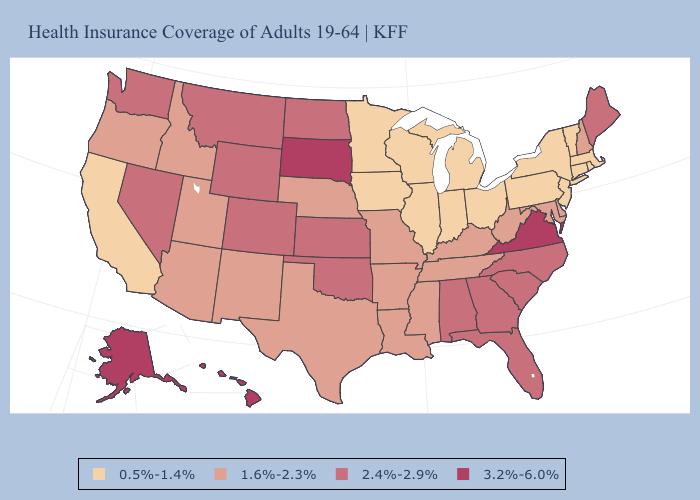Is the legend a continuous bar?
Write a very short answer. No. Name the states that have a value in the range 2.4%-2.9%?
Answer briefly. Alabama, Colorado, Florida, Georgia, Kansas, Maine, Montana, Nevada, North Carolina, North Dakota, Oklahoma, South Carolina, Washington, Wyoming. Name the states that have a value in the range 1.6%-2.3%?
Give a very brief answer. Arizona, Arkansas, Delaware, Idaho, Kentucky, Louisiana, Maryland, Mississippi, Missouri, Nebraska, New Hampshire, New Mexico, Oregon, Tennessee, Texas, Utah, West Virginia. Does Louisiana have a higher value than Hawaii?
Answer briefly. No. Among the states that border Kansas , does Nebraska have the lowest value?
Answer briefly. Yes. What is the value of Virginia?
Give a very brief answer. 3.2%-6.0%. What is the lowest value in states that border Maryland?
Keep it brief. 0.5%-1.4%. Among the states that border Colorado , does Kansas have the lowest value?
Write a very short answer. No. Which states have the highest value in the USA?
Keep it brief. Alaska, Hawaii, South Dakota, Virginia. What is the lowest value in the West?
Be succinct. 0.5%-1.4%. Name the states that have a value in the range 2.4%-2.9%?
Quick response, please. Alabama, Colorado, Florida, Georgia, Kansas, Maine, Montana, Nevada, North Carolina, North Dakota, Oklahoma, South Carolina, Washington, Wyoming. Does Arizona have the same value as Idaho?
Keep it brief. Yes. Does Washington have the highest value in the USA?
Quick response, please. No. Does Montana have the lowest value in the USA?
Write a very short answer. No. What is the highest value in the West ?
Short answer required. 3.2%-6.0%. 